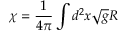<formula> <loc_0><loc_0><loc_500><loc_500>\chi = \frac { 1 } { 4 \pi } \int d ^ { 2 } x \sqrt { g } R</formula> 